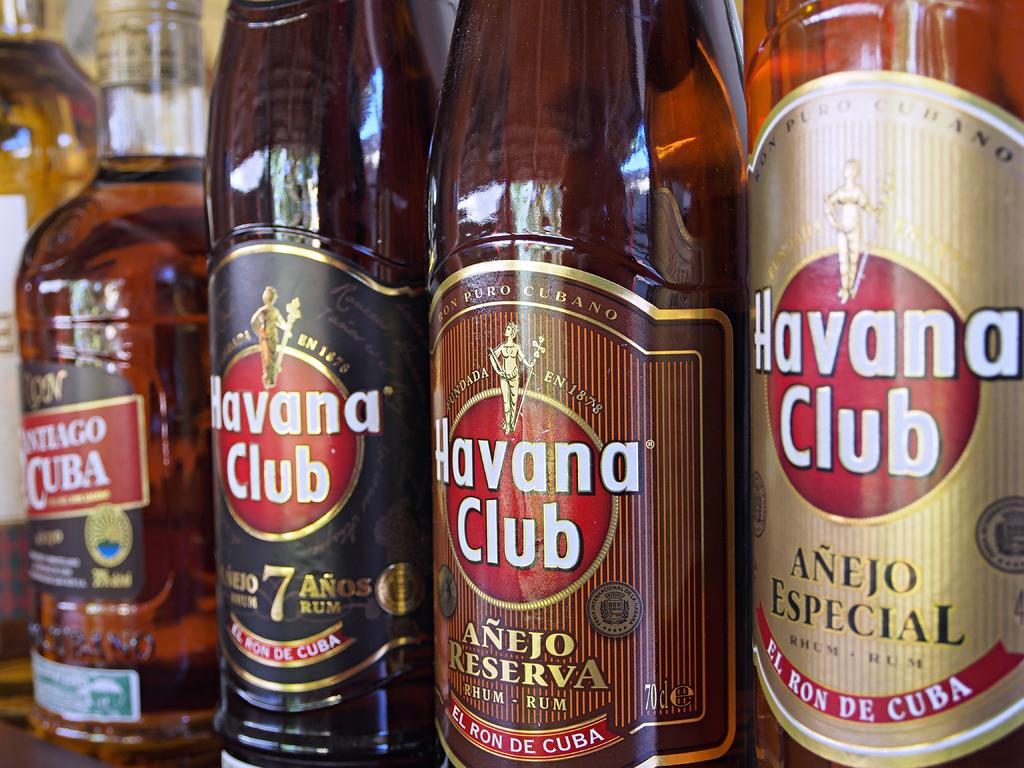<image>
Relay a brief, clear account of the picture shown. a row of bottles all labeled 'havana club' on them 